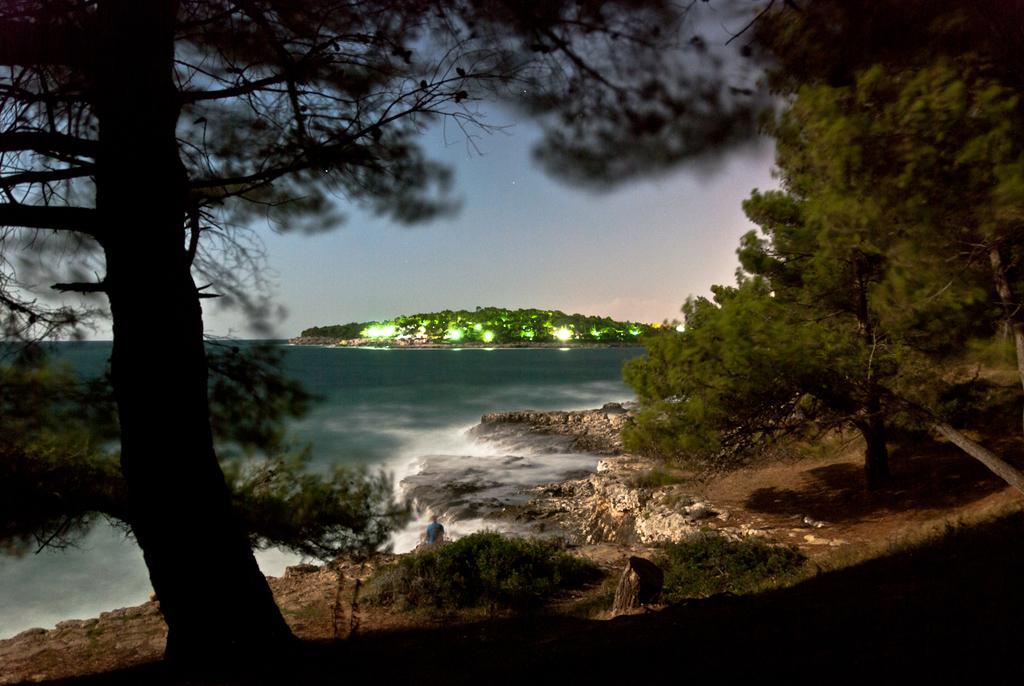Can you describe this image briefly? In this image a person is standing on the land having few plants and trees. Middle of the image there is water. Beside there is land having few trees and lights on it. Top of it there is sky. 